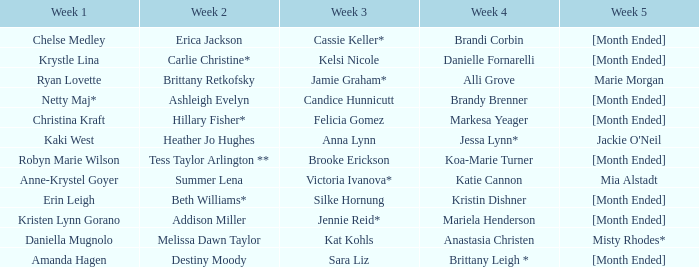What is the second week with daniella mugnolo following the first week? Melissa Dawn Taylor. 